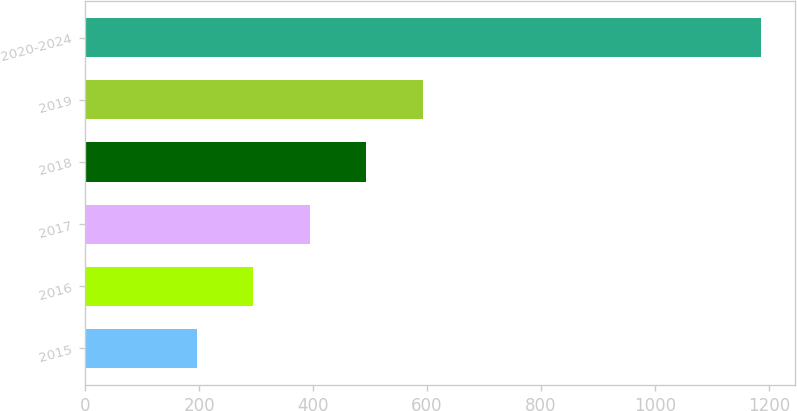Convert chart. <chart><loc_0><loc_0><loc_500><loc_500><bar_chart><fcel>2015<fcel>2016<fcel>2017<fcel>2018<fcel>2019<fcel>2020-2024<nl><fcel>196<fcel>295.1<fcel>394.2<fcel>493.3<fcel>592.4<fcel>1187<nl></chart> 